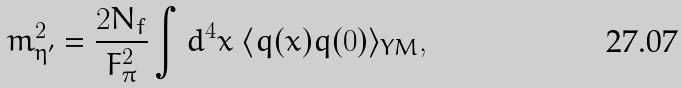Convert formula to latex. <formula><loc_0><loc_0><loc_500><loc_500>m _ { \eta ^ { \prime } } ^ { 2 } = \frac { 2 N _ { f } } { F _ { \pi } ^ { 2 } } \int d ^ { 4 } x \ \langle q ( x ) q ( 0 ) \rangle _ { Y M } ,</formula> 